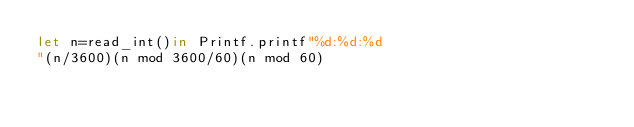Convert code to text. <code><loc_0><loc_0><loc_500><loc_500><_OCaml_>let n=read_int()in Printf.printf"%d:%d:%d
"(n/3600)(n mod 3600/60)(n mod 60)</code> 